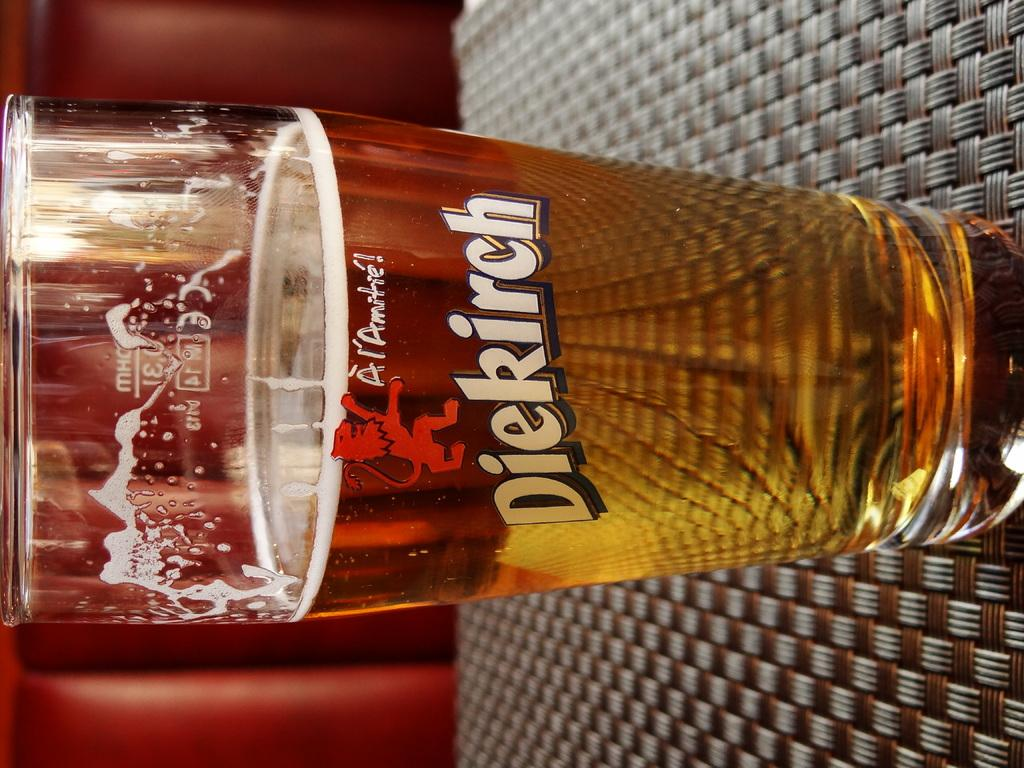Provide a one-sentence caption for the provided image. Glass of beer in a dierirch glass that is half way full. 